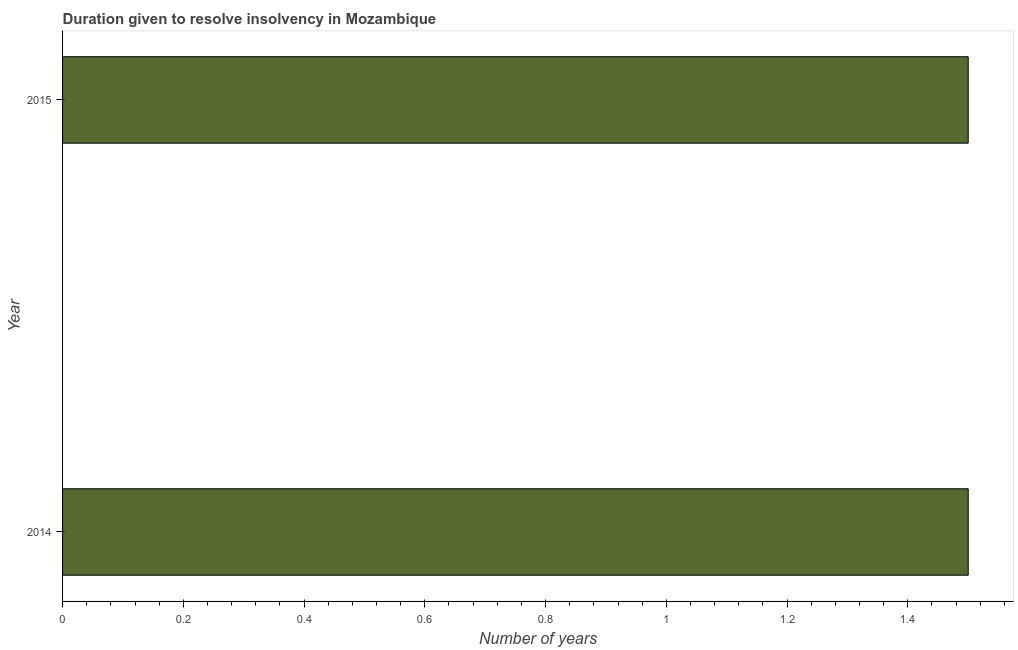Does the graph contain any zero values?
Your answer should be very brief. No. What is the title of the graph?
Provide a short and direct response. Duration given to resolve insolvency in Mozambique. What is the label or title of the X-axis?
Your response must be concise. Number of years. What is the label or title of the Y-axis?
Keep it short and to the point. Year. What is the number of years to resolve insolvency in 2015?
Give a very brief answer. 1.5. Across all years, what is the maximum number of years to resolve insolvency?
Provide a short and direct response. 1.5. Across all years, what is the minimum number of years to resolve insolvency?
Offer a very short reply. 1.5. In which year was the number of years to resolve insolvency maximum?
Make the answer very short. 2014. In which year was the number of years to resolve insolvency minimum?
Offer a very short reply. 2014. What is the sum of the number of years to resolve insolvency?
Offer a very short reply. 3. What is the difference between the number of years to resolve insolvency in 2014 and 2015?
Provide a succinct answer. 0. What is the median number of years to resolve insolvency?
Provide a short and direct response. 1.5. In how many years, is the number of years to resolve insolvency greater than 0.6 ?
Your answer should be compact. 2. What is the ratio of the number of years to resolve insolvency in 2014 to that in 2015?
Your response must be concise. 1. How many bars are there?
Your response must be concise. 2. How many years are there in the graph?
Offer a very short reply. 2. What is the difference between two consecutive major ticks on the X-axis?
Give a very brief answer. 0.2. What is the Number of years in 2015?
Make the answer very short. 1.5. What is the difference between the Number of years in 2014 and 2015?
Your response must be concise. 0. What is the ratio of the Number of years in 2014 to that in 2015?
Provide a short and direct response. 1. 